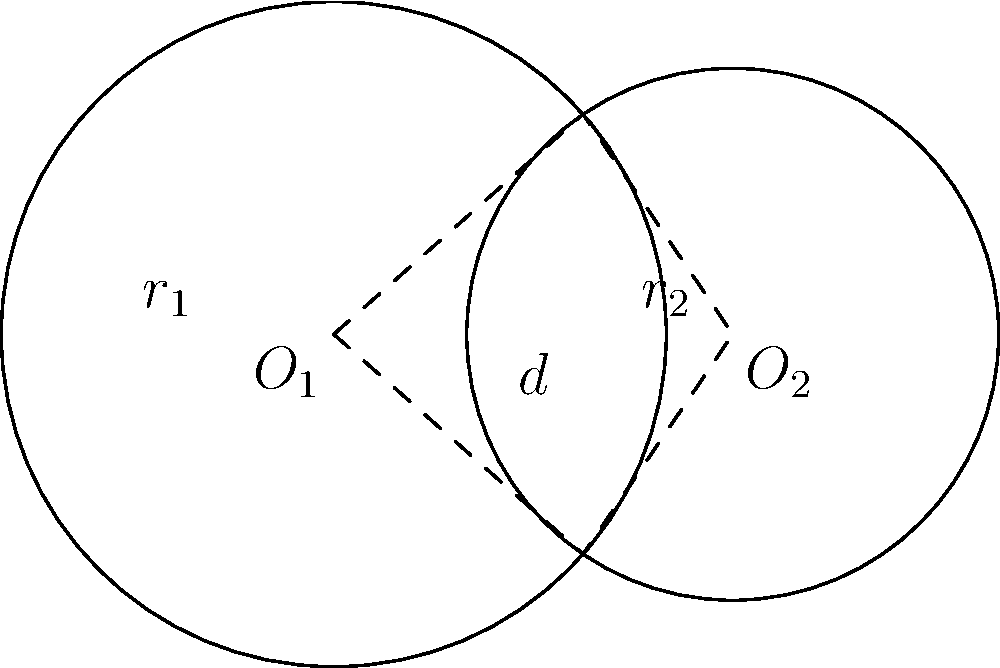Given two intersecting circles with centers $O_1$ and $O_2$, radii $r_1 = 2.5$ and $r_2 = 2$ respectively, and a distance $d = 3$ between their centers, determine the area of the overlapping region. Express your answer in terms of $\pi$. To find the area of overlap between two intersecting circles, we'll use the following steps:

1) First, we need to calculate the central angle $\theta_1$ for circle 1 and $\theta_2$ for circle 2 using the cosine law:

   $\cos(\frac{\theta_1}{2}) = \frac{d^2 + r_1^2 - r_2^2}{2dr_1}$
   $\cos(\frac{\theta_2}{2}) = \frac{d^2 + r_2^2 - r_1^2}{2dr_2}$

2) Substitute the values:
   $\cos(\frac{\theta_1}{2}) = \frac{3^2 + 2.5^2 - 2^2}{2 \cdot 3 \cdot 2.5} = 0.7$
   $\cos(\frac{\theta_2}{2}) = \frac{3^2 + 2^2 - 2.5^2}{2 \cdot 3 \cdot 2} = 0.5$

3) Calculate $\theta_1$ and $\theta_2$:
   $\theta_1 = 2 \arccos(0.7) \approx 1.5904$ radians
   $\theta_2 = 2 \arccos(0.5) \approx 2.0944$ radians

4) The area of overlap is the sum of two circular sectors minus the area of the rhombus formed by the radii:

   $A = \frac{1}{2}r_1^2\theta_1 + \frac{1}{2}r_2^2\theta_2 - r_1r_2\sin(\frac{\theta_1}{2})$

5) Substitute the values:
   $A = \frac{1}{2}(2.5)^2(1.5904) + \frac{1}{2}(2)^2(2.0944) - 2.5 \cdot 2 \cdot \sin(0.7952)$
   $A \approx 4.9700 + 4.1888 - 3.5355$
   $A \approx 5.6233$

6) Express in terms of $\pi$:
   $A \approx 1.7893\pi$

Therefore, the area of overlap is approximately $1.7893\pi$ square units.
Answer: $1.7893\pi$ square units 